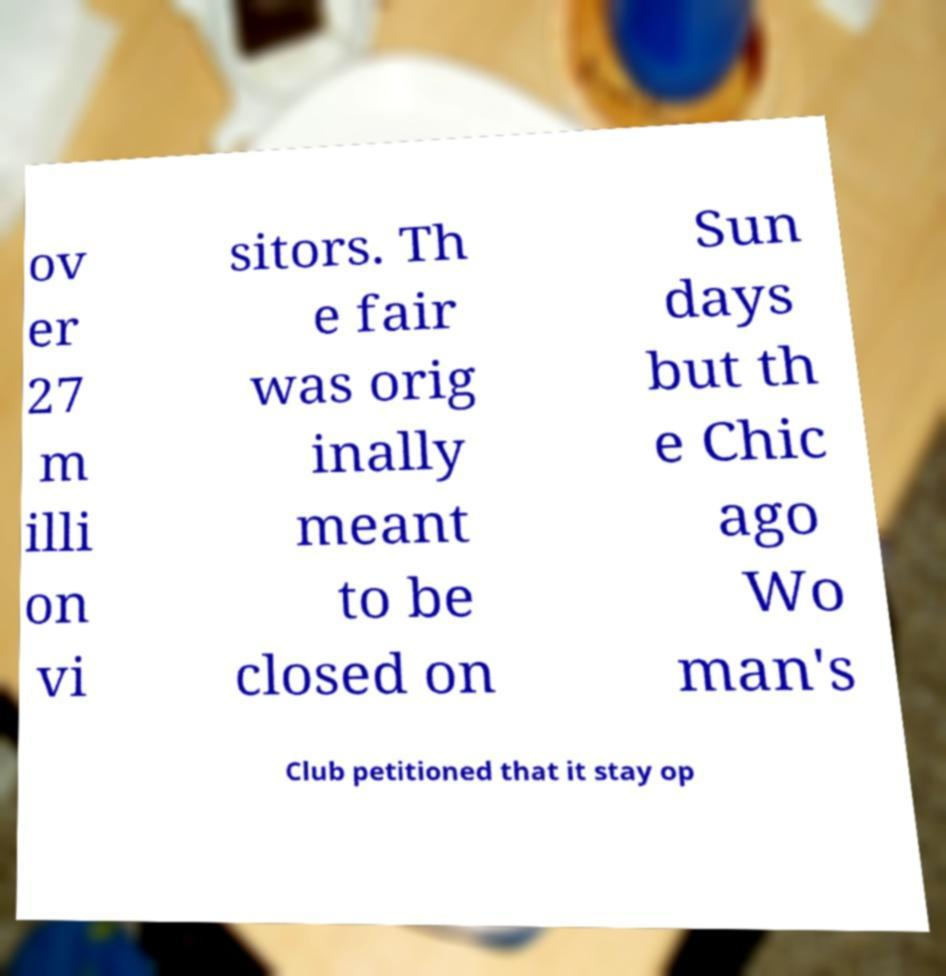What messages or text are displayed in this image? I need them in a readable, typed format. ov er 27 m illi on vi sitors. Th e fair was orig inally meant to be closed on Sun days but th e Chic ago Wo man's Club petitioned that it stay op 